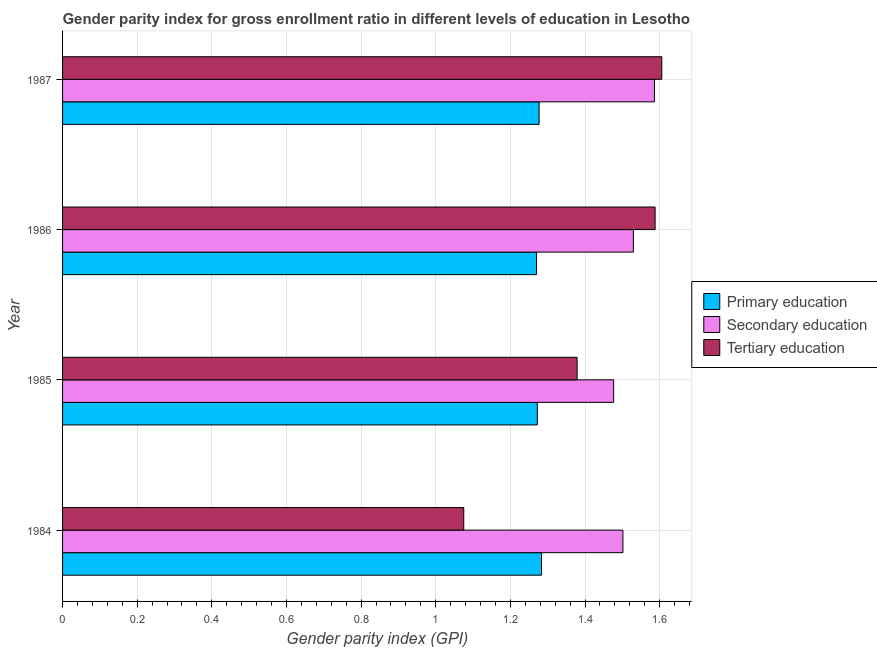Are the number of bars per tick equal to the number of legend labels?
Offer a terse response. Yes. How many bars are there on the 3rd tick from the bottom?
Give a very brief answer. 3. In how many cases, is the number of bars for a given year not equal to the number of legend labels?
Provide a short and direct response. 0. What is the gender parity index in tertiary education in 1984?
Your answer should be compact. 1.08. Across all years, what is the maximum gender parity index in primary education?
Provide a succinct answer. 1.28. Across all years, what is the minimum gender parity index in primary education?
Make the answer very short. 1.27. In which year was the gender parity index in primary education maximum?
Make the answer very short. 1984. What is the total gender parity index in tertiary education in the graph?
Your answer should be compact. 5.65. What is the difference between the gender parity index in primary education in 1984 and that in 1987?
Your answer should be very brief. 0.01. What is the difference between the gender parity index in secondary education in 1985 and the gender parity index in primary education in 1986?
Your answer should be compact. 0.21. What is the average gender parity index in secondary education per year?
Keep it short and to the point. 1.52. In the year 1987, what is the difference between the gender parity index in primary education and gender parity index in tertiary education?
Offer a terse response. -0.33. What is the ratio of the gender parity index in tertiary education in 1985 to that in 1986?
Make the answer very short. 0.87. Is the gender parity index in secondary education in 1986 less than that in 1987?
Your answer should be very brief. Yes. Is the difference between the gender parity index in primary education in 1985 and 1986 greater than the difference between the gender parity index in secondary education in 1985 and 1986?
Ensure brevity in your answer.  Yes. What is the difference between the highest and the second highest gender parity index in primary education?
Offer a terse response. 0.01. What is the difference between the highest and the lowest gender parity index in primary education?
Ensure brevity in your answer.  0.01. In how many years, is the gender parity index in primary education greater than the average gender parity index in primary education taken over all years?
Offer a very short reply. 2. What does the 2nd bar from the top in 1987 represents?
Provide a short and direct response. Secondary education. What does the 2nd bar from the bottom in 1987 represents?
Keep it short and to the point. Secondary education. Is it the case that in every year, the sum of the gender parity index in primary education and gender parity index in secondary education is greater than the gender parity index in tertiary education?
Your answer should be very brief. Yes. Are all the bars in the graph horizontal?
Your response must be concise. Yes. How many years are there in the graph?
Provide a short and direct response. 4. Does the graph contain any zero values?
Make the answer very short. No. Where does the legend appear in the graph?
Keep it short and to the point. Center right. What is the title of the graph?
Your answer should be compact. Gender parity index for gross enrollment ratio in different levels of education in Lesotho. What is the label or title of the X-axis?
Provide a short and direct response. Gender parity index (GPI). What is the Gender parity index (GPI) in Primary education in 1984?
Ensure brevity in your answer.  1.28. What is the Gender parity index (GPI) in Secondary education in 1984?
Your answer should be compact. 1.5. What is the Gender parity index (GPI) in Tertiary education in 1984?
Provide a short and direct response. 1.08. What is the Gender parity index (GPI) of Primary education in 1985?
Give a very brief answer. 1.27. What is the Gender parity index (GPI) of Secondary education in 1985?
Make the answer very short. 1.48. What is the Gender parity index (GPI) of Tertiary education in 1985?
Your answer should be compact. 1.38. What is the Gender parity index (GPI) of Primary education in 1986?
Make the answer very short. 1.27. What is the Gender parity index (GPI) of Secondary education in 1986?
Your answer should be compact. 1.53. What is the Gender parity index (GPI) in Tertiary education in 1986?
Your answer should be very brief. 1.59. What is the Gender parity index (GPI) in Primary education in 1987?
Make the answer very short. 1.28. What is the Gender parity index (GPI) in Secondary education in 1987?
Offer a terse response. 1.59. What is the Gender parity index (GPI) of Tertiary education in 1987?
Offer a terse response. 1.61. Across all years, what is the maximum Gender parity index (GPI) in Primary education?
Give a very brief answer. 1.28. Across all years, what is the maximum Gender parity index (GPI) of Secondary education?
Make the answer very short. 1.59. Across all years, what is the maximum Gender parity index (GPI) in Tertiary education?
Offer a very short reply. 1.61. Across all years, what is the minimum Gender parity index (GPI) of Primary education?
Your answer should be compact. 1.27. Across all years, what is the minimum Gender parity index (GPI) of Secondary education?
Your answer should be very brief. 1.48. Across all years, what is the minimum Gender parity index (GPI) in Tertiary education?
Provide a succinct answer. 1.08. What is the total Gender parity index (GPI) of Primary education in the graph?
Keep it short and to the point. 5.1. What is the total Gender parity index (GPI) in Secondary education in the graph?
Offer a very short reply. 6.09. What is the total Gender parity index (GPI) in Tertiary education in the graph?
Give a very brief answer. 5.65. What is the difference between the Gender parity index (GPI) in Primary education in 1984 and that in 1985?
Your response must be concise. 0.01. What is the difference between the Gender parity index (GPI) in Secondary education in 1984 and that in 1985?
Give a very brief answer. 0.02. What is the difference between the Gender parity index (GPI) of Tertiary education in 1984 and that in 1985?
Your response must be concise. -0.3. What is the difference between the Gender parity index (GPI) in Primary education in 1984 and that in 1986?
Give a very brief answer. 0.01. What is the difference between the Gender parity index (GPI) of Secondary education in 1984 and that in 1986?
Offer a terse response. -0.03. What is the difference between the Gender parity index (GPI) in Tertiary education in 1984 and that in 1986?
Your response must be concise. -0.51. What is the difference between the Gender parity index (GPI) in Primary education in 1984 and that in 1987?
Provide a succinct answer. 0.01. What is the difference between the Gender parity index (GPI) of Secondary education in 1984 and that in 1987?
Offer a terse response. -0.08. What is the difference between the Gender parity index (GPI) in Tertiary education in 1984 and that in 1987?
Make the answer very short. -0.53. What is the difference between the Gender parity index (GPI) of Primary education in 1985 and that in 1986?
Your response must be concise. 0. What is the difference between the Gender parity index (GPI) of Secondary education in 1985 and that in 1986?
Make the answer very short. -0.05. What is the difference between the Gender parity index (GPI) in Tertiary education in 1985 and that in 1986?
Your response must be concise. -0.21. What is the difference between the Gender parity index (GPI) in Primary education in 1985 and that in 1987?
Give a very brief answer. -0. What is the difference between the Gender parity index (GPI) of Secondary education in 1985 and that in 1987?
Ensure brevity in your answer.  -0.11. What is the difference between the Gender parity index (GPI) in Tertiary education in 1985 and that in 1987?
Give a very brief answer. -0.23. What is the difference between the Gender parity index (GPI) of Primary education in 1986 and that in 1987?
Give a very brief answer. -0.01. What is the difference between the Gender parity index (GPI) of Secondary education in 1986 and that in 1987?
Give a very brief answer. -0.06. What is the difference between the Gender parity index (GPI) in Tertiary education in 1986 and that in 1987?
Provide a short and direct response. -0.02. What is the difference between the Gender parity index (GPI) of Primary education in 1984 and the Gender parity index (GPI) of Secondary education in 1985?
Offer a very short reply. -0.19. What is the difference between the Gender parity index (GPI) of Primary education in 1984 and the Gender parity index (GPI) of Tertiary education in 1985?
Ensure brevity in your answer.  -0.1. What is the difference between the Gender parity index (GPI) in Secondary education in 1984 and the Gender parity index (GPI) in Tertiary education in 1985?
Make the answer very short. 0.12. What is the difference between the Gender parity index (GPI) of Primary education in 1984 and the Gender parity index (GPI) of Secondary education in 1986?
Your answer should be compact. -0.25. What is the difference between the Gender parity index (GPI) in Primary education in 1984 and the Gender parity index (GPI) in Tertiary education in 1986?
Keep it short and to the point. -0.3. What is the difference between the Gender parity index (GPI) of Secondary education in 1984 and the Gender parity index (GPI) of Tertiary education in 1986?
Ensure brevity in your answer.  -0.09. What is the difference between the Gender parity index (GPI) in Primary education in 1984 and the Gender parity index (GPI) in Secondary education in 1987?
Keep it short and to the point. -0.3. What is the difference between the Gender parity index (GPI) in Primary education in 1984 and the Gender parity index (GPI) in Tertiary education in 1987?
Your answer should be very brief. -0.32. What is the difference between the Gender parity index (GPI) in Secondary education in 1984 and the Gender parity index (GPI) in Tertiary education in 1987?
Your response must be concise. -0.1. What is the difference between the Gender parity index (GPI) in Primary education in 1985 and the Gender parity index (GPI) in Secondary education in 1986?
Offer a very short reply. -0.26. What is the difference between the Gender parity index (GPI) in Primary education in 1985 and the Gender parity index (GPI) in Tertiary education in 1986?
Your answer should be very brief. -0.32. What is the difference between the Gender parity index (GPI) of Secondary education in 1985 and the Gender parity index (GPI) of Tertiary education in 1986?
Provide a succinct answer. -0.11. What is the difference between the Gender parity index (GPI) of Primary education in 1985 and the Gender parity index (GPI) of Secondary education in 1987?
Your response must be concise. -0.31. What is the difference between the Gender parity index (GPI) of Primary education in 1985 and the Gender parity index (GPI) of Tertiary education in 1987?
Your answer should be very brief. -0.33. What is the difference between the Gender parity index (GPI) in Secondary education in 1985 and the Gender parity index (GPI) in Tertiary education in 1987?
Make the answer very short. -0.13. What is the difference between the Gender parity index (GPI) of Primary education in 1986 and the Gender parity index (GPI) of Secondary education in 1987?
Give a very brief answer. -0.32. What is the difference between the Gender parity index (GPI) of Primary education in 1986 and the Gender parity index (GPI) of Tertiary education in 1987?
Keep it short and to the point. -0.34. What is the difference between the Gender parity index (GPI) in Secondary education in 1986 and the Gender parity index (GPI) in Tertiary education in 1987?
Offer a very short reply. -0.08. What is the average Gender parity index (GPI) of Primary education per year?
Offer a terse response. 1.28. What is the average Gender parity index (GPI) in Secondary education per year?
Make the answer very short. 1.52. What is the average Gender parity index (GPI) in Tertiary education per year?
Ensure brevity in your answer.  1.41. In the year 1984, what is the difference between the Gender parity index (GPI) in Primary education and Gender parity index (GPI) in Secondary education?
Offer a terse response. -0.22. In the year 1984, what is the difference between the Gender parity index (GPI) of Primary education and Gender parity index (GPI) of Tertiary education?
Your response must be concise. 0.21. In the year 1984, what is the difference between the Gender parity index (GPI) of Secondary education and Gender parity index (GPI) of Tertiary education?
Offer a very short reply. 0.43. In the year 1985, what is the difference between the Gender parity index (GPI) of Primary education and Gender parity index (GPI) of Secondary education?
Keep it short and to the point. -0.2. In the year 1985, what is the difference between the Gender parity index (GPI) in Primary education and Gender parity index (GPI) in Tertiary education?
Your answer should be compact. -0.11. In the year 1985, what is the difference between the Gender parity index (GPI) of Secondary education and Gender parity index (GPI) of Tertiary education?
Your response must be concise. 0.1. In the year 1986, what is the difference between the Gender parity index (GPI) of Primary education and Gender parity index (GPI) of Secondary education?
Provide a short and direct response. -0.26. In the year 1986, what is the difference between the Gender parity index (GPI) of Primary education and Gender parity index (GPI) of Tertiary education?
Give a very brief answer. -0.32. In the year 1986, what is the difference between the Gender parity index (GPI) in Secondary education and Gender parity index (GPI) in Tertiary education?
Keep it short and to the point. -0.06. In the year 1987, what is the difference between the Gender parity index (GPI) in Primary education and Gender parity index (GPI) in Secondary education?
Provide a succinct answer. -0.31. In the year 1987, what is the difference between the Gender parity index (GPI) in Primary education and Gender parity index (GPI) in Tertiary education?
Ensure brevity in your answer.  -0.33. In the year 1987, what is the difference between the Gender parity index (GPI) of Secondary education and Gender parity index (GPI) of Tertiary education?
Provide a succinct answer. -0.02. What is the ratio of the Gender parity index (GPI) of Primary education in 1984 to that in 1985?
Your answer should be compact. 1.01. What is the ratio of the Gender parity index (GPI) in Secondary education in 1984 to that in 1985?
Give a very brief answer. 1.02. What is the ratio of the Gender parity index (GPI) of Tertiary education in 1984 to that in 1985?
Provide a succinct answer. 0.78. What is the ratio of the Gender parity index (GPI) of Primary education in 1984 to that in 1986?
Your answer should be very brief. 1.01. What is the ratio of the Gender parity index (GPI) of Secondary education in 1984 to that in 1986?
Provide a succinct answer. 0.98. What is the ratio of the Gender parity index (GPI) of Tertiary education in 1984 to that in 1986?
Your answer should be very brief. 0.68. What is the ratio of the Gender parity index (GPI) in Primary education in 1984 to that in 1987?
Provide a short and direct response. 1. What is the ratio of the Gender parity index (GPI) of Secondary education in 1984 to that in 1987?
Provide a succinct answer. 0.95. What is the ratio of the Gender parity index (GPI) in Tertiary education in 1984 to that in 1987?
Your answer should be very brief. 0.67. What is the ratio of the Gender parity index (GPI) of Secondary education in 1985 to that in 1986?
Provide a short and direct response. 0.97. What is the ratio of the Gender parity index (GPI) in Tertiary education in 1985 to that in 1986?
Your answer should be very brief. 0.87. What is the ratio of the Gender parity index (GPI) in Secondary education in 1985 to that in 1987?
Give a very brief answer. 0.93. What is the ratio of the Gender parity index (GPI) in Tertiary education in 1985 to that in 1987?
Provide a short and direct response. 0.86. What is the ratio of the Gender parity index (GPI) of Secondary education in 1986 to that in 1987?
Offer a very short reply. 0.96. What is the difference between the highest and the second highest Gender parity index (GPI) in Primary education?
Your answer should be compact. 0.01. What is the difference between the highest and the second highest Gender parity index (GPI) in Secondary education?
Provide a succinct answer. 0.06. What is the difference between the highest and the second highest Gender parity index (GPI) of Tertiary education?
Ensure brevity in your answer.  0.02. What is the difference between the highest and the lowest Gender parity index (GPI) of Primary education?
Your response must be concise. 0.01. What is the difference between the highest and the lowest Gender parity index (GPI) of Secondary education?
Your response must be concise. 0.11. What is the difference between the highest and the lowest Gender parity index (GPI) of Tertiary education?
Keep it short and to the point. 0.53. 